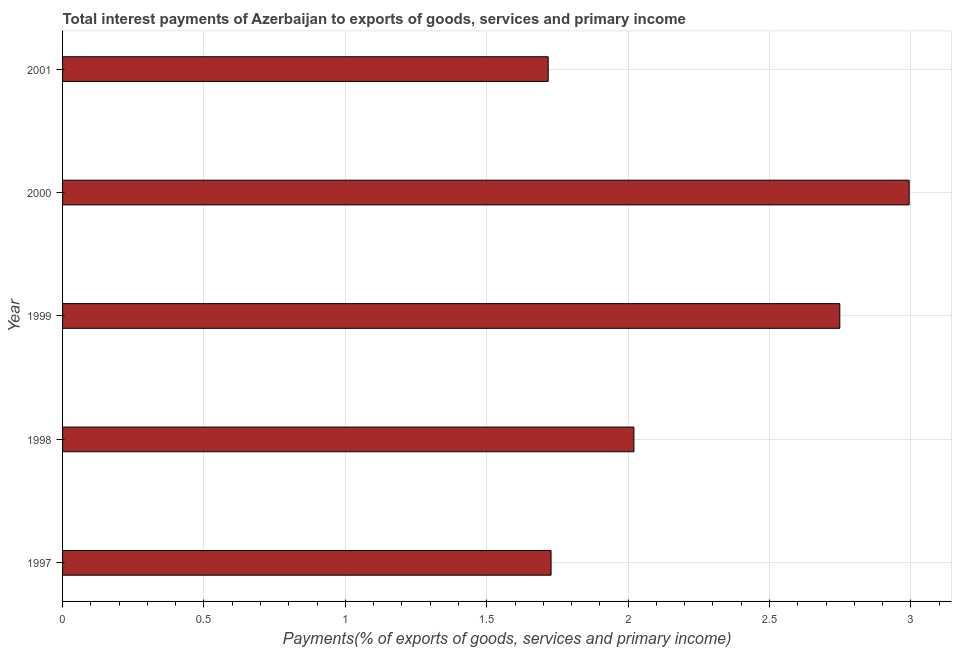Does the graph contain any zero values?
Keep it short and to the point. No. What is the title of the graph?
Offer a terse response. Total interest payments of Azerbaijan to exports of goods, services and primary income. What is the label or title of the X-axis?
Your response must be concise. Payments(% of exports of goods, services and primary income). What is the label or title of the Y-axis?
Offer a very short reply. Year. What is the total interest payments on external debt in 2000?
Give a very brief answer. 2.99. Across all years, what is the maximum total interest payments on external debt?
Provide a succinct answer. 2.99. Across all years, what is the minimum total interest payments on external debt?
Provide a short and direct response. 1.72. In which year was the total interest payments on external debt minimum?
Offer a very short reply. 2001. What is the sum of the total interest payments on external debt?
Offer a terse response. 11.21. What is the difference between the total interest payments on external debt in 1997 and 1999?
Your answer should be very brief. -1.02. What is the average total interest payments on external debt per year?
Offer a very short reply. 2.24. What is the median total interest payments on external debt?
Your answer should be very brief. 2.02. In how many years, is the total interest payments on external debt greater than 2.4 %?
Give a very brief answer. 2. Do a majority of the years between 2000 and 1997 (inclusive) have total interest payments on external debt greater than 0.2 %?
Your response must be concise. Yes. What is the ratio of the total interest payments on external debt in 1997 to that in 1998?
Keep it short and to the point. 0.85. Is the total interest payments on external debt in 1997 less than that in 2001?
Ensure brevity in your answer.  No. What is the difference between the highest and the second highest total interest payments on external debt?
Provide a succinct answer. 0.24. What is the difference between the highest and the lowest total interest payments on external debt?
Keep it short and to the point. 1.28. How many bars are there?
Offer a very short reply. 5. How many years are there in the graph?
Give a very brief answer. 5. What is the Payments(% of exports of goods, services and primary income) in 1997?
Ensure brevity in your answer.  1.73. What is the Payments(% of exports of goods, services and primary income) in 1998?
Your answer should be very brief. 2.02. What is the Payments(% of exports of goods, services and primary income) in 1999?
Keep it short and to the point. 2.75. What is the Payments(% of exports of goods, services and primary income) in 2000?
Ensure brevity in your answer.  2.99. What is the Payments(% of exports of goods, services and primary income) of 2001?
Give a very brief answer. 1.72. What is the difference between the Payments(% of exports of goods, services and primary income) in 1997 and 1998?
Your answer should be very brief. -0.29. What is the difference between the Payments(% of exports of goods, services and primary income) in 1997 and 1999?
Make the answer very short. -1.02. What is the difference between the Payments(% of exports of goods, services and primary income) in 1997 and 2000?
Ensure brevity in your answer.  -1.27. What is the difference between the Payments(% of exports of goods, services and primary income) in 1997 and 2001?
Ensure brevity in your answer.  0.01. What is the difference between the Payments(% of exports of goods, services and primary income) in 1998 and 1999?
Offer a terse response. -0.73. What is the difference between the Payments(% of exports of goods, services and primary income) in 1998 and 2000?
Provide a succinct answer. -0.97. What is the difference between the Payments(% of exports of goods, services and primary income) in 1998 and 2001?
Ensure brevity in your answer.  0.3. What is the difference between the Payments(% of exports of goods, services and primary income) in 1999 and 2000?
Provide a succinct answer. -0.25. What is the difference between the Payments(% of exports of goods, services and primary income) in 1999 and 2001?
Make the answer very short. 1.03. What is the difference between the Payments(% of exports of goods, services and primary income) in 2000 and 2001?
Ensure brevity in your answer.  1.28. What is the ratio of the Payments(% of exports of goods, services and primary income) in 1997 to that in 1998?
Ensure brevity in your answer.  0.85. What is the ratio of the Payments(% of exports of goods, services and primary income) in 1997 to that in 1999?
Your answer should be very brief. 0.63. What is the ratio of the Payments(% of exports of goods, services and primary income) in 1997 to that in 2000?
Your answer should be compact. 0.58. What is the ratio of the Payments(% of exports of goods, services and primary income) in 1997 to that in 2001?
Ensure brevity in your answer.  1.01. What is the ratio of the Payments(% of exports of goods, services and primary income) in 1998 to that in 1999?
Give a very brief answer. 0.73. What is the ratio of the Payments(% of exports of goods, services and primary income) in 1998 to that in 2000?
Ensure brevity in your answer.  0.68. What is the ratio of the Payments(% of exports of goods, services and primary income) in 1998 to that in 2001?
Provide a succinct answer. 1.18. What is the ratio of the Payments(% of exports of goods, services and primary income) in 1999 to that in 2000?
Provide a succinct answer. 0.92. What is the ratio of the Payments(% of exports of goods, services and primary income) in 2000 to that in 2001?
Keep it short and to the point. 1.74. 